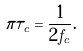Convert formula to latex. <formula><loc_0><loc_0><loc_500><loc_500>\pi \tau _ { c } = \frac { 1 } { 2 f _ { c } } .</formula> 